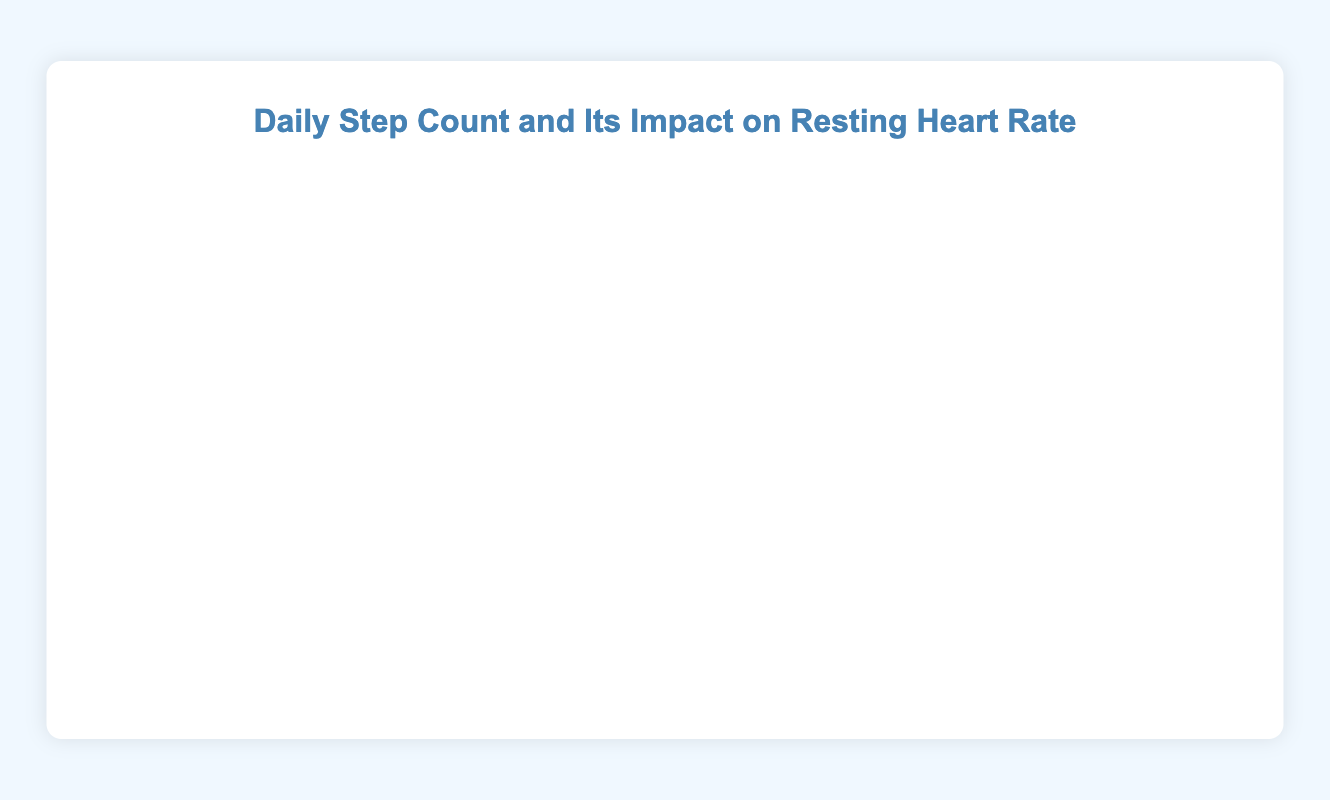What's the average daily step count in the months of January and February? First, identify the data points from January and February. Sum the daily step counts: (3000 + 3200 + 3500 + 3800 + 4000 + 4200 + 4500 + 4800 + 5000) = 36000. There are 9 data points, so the average is 36000 / 9.
Answer: 4000 Which time period shows the greatest decrease in resting heart rate? Compare the change in resting heart rate over each time period visually. Look for the steepest downward slope in the red line. The period from January to December shows a more significant and consistent decrease.
Answer: January to December By how much did the resting heart rate drop from the beginning to the end of the year? The resting heart rate at the start is 75 bpm (January 1). At the end of the year, it is 49 bpm (December 31). The drop is 75 - 49.
Answer: 26 bpm Is there any point where the resting heart rate remains constant despite an increase in daily step count? Observe both lines; check if there is any period where the red line (resting heart rate) remains flat while the blue line (daily step count) increases. For example, from January 8 to January 15, the resting heart rate remains at 74 bpm while steps increase from 3200 to 3500.
Answer: Yes, January 8 to January 15 When did the daily step count exceed 10,000 for the first time, and what was the resting heart rate then? Look for the first time the blue line crosses the 10,000 mark on the x-axis and check the corresponding red line value. The daily step count exceeds 10,000 on July 9, 2022, and the resting heart rate is 61 bpm.
Answer: July 9, 61 bpm What's the average resting heart rate over the year? Sum the resting heart rates for all the data points and divide by the number of points. (Sum = 75 + 74 + 74 + 73 + 73 + 72 + 72 + 71 + 71 + 70 + 70 + 69 + 69 + 68 + 68 + 67 + 67 + 66 + 66 + 65 + 65 + 64 + 64 + 63 + 63 + 62 + 62 + 61 + 61 + 60 + 60 + 59 + 59 + 58 + 58 + 57 + 57 + 56 + 56 + 55 + 55 + 54 + 54 + 53 + 53 + 52 + 52 + 51 + 51 + 50 + 50 + 49 + 49) = 3474, divided by 53 data points.
Answer: 65.56 bpm Compare the resting heart rates on April 2 and October 1. Which date had a higher rate, and by how much? From the chart, the resting heart rate on April 2 is 68 bpm, and on October 1, it is 55 bpm. Calculate the difference: 68 - 55.
Answer: April 2, by 13 bpm What is the overall trend in daily step count and resting heart rate over the year? Visually inspect the chart; the blue line (daily step count) generally trends upwards, while the red line (resting heart rate) trends downwards. Thus, the step count increases, and the heart rate decreases over the year.
Answer: Increasing steps, decreasing heart rate 